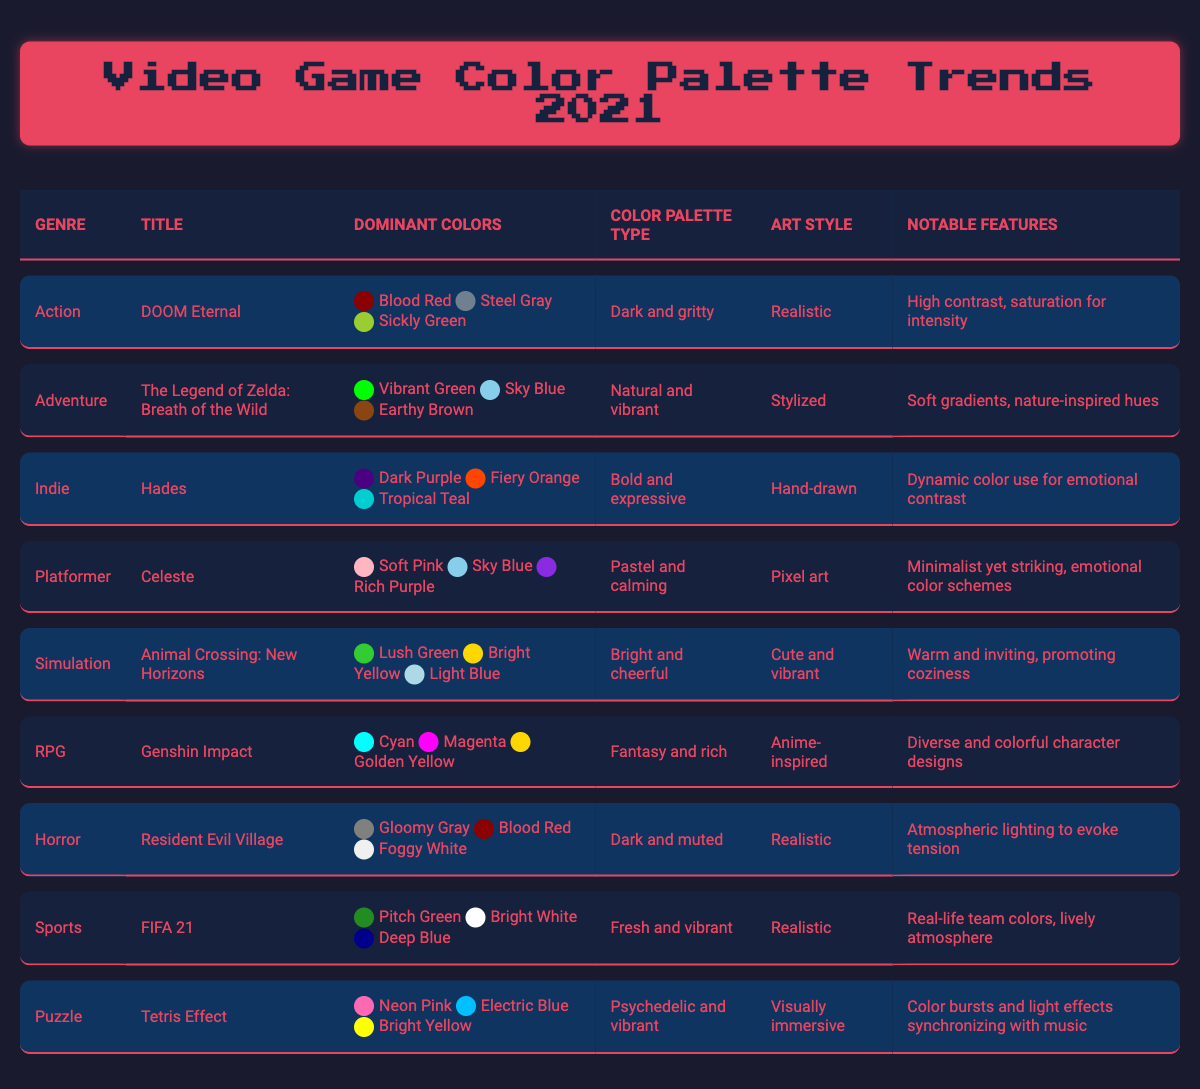What's the dominant color in "DOOM Eternal"? The table shows that the dominant colors for "DOOM Eternal" are "Blood Red," "Steel Gray," and "Sickly Green." The first listed color, "Blood Red," is typically considered the most dominant.
Answer: Blood Red Which genre does "Animal Crossing: New Horizons" belong to? Looking at the table, "Animal Crossing: New Horizons" is listed under the genre "Simulation."
Answer: Simulation What is the color palette type for "Hades"? In the table, the color palette type for "Hades" is described as "bold and expressive."
Answer: Bold and expressive True or False: "Celeste" has a color palette that is described as bright and cheerful. The table shows that "Celeste" has a color palette type of "pastel and calming," not "bright and cheerful." Hence, the statement is false.
Answer: False What are the top three dominant colors used in "Resident Evil Village"? The table states that the dominant colors for "Resident Evil Village" are "Gloomy Gray," "Blood Red," and "Foggy White."
Answer: Gloomy Gray, Blood Red, Foggy White Which art style is used in "Genshin Impact"? According to the table, "Genshin Impact" has an art style described as "anime-inspired."
Answer: Anime-inspired What is the average number of dominant colors for the listed games? There are nine games listed, each with three dominant colors. So, the total number of dominant colors is 9 games × 3 colors = 27 colors, and the average is 27/9 = 3.
Answer: 3 Which game has a color palette that is "dark and gritty"? The table indicates that "DOOM Eternal" has a color palette type described as "dark and gritty."
Answer: DOOM Eternal What is the notable feature of the color palette used in "Tetris Effect"? The notable feature of the color palette used in "Tetris Effect," as per the table, is "Color bursts and light effects synchronizing with music."
Answer: Color bursts and light effects synchronizing with music If a player enjoys vibrant greens and pastel colors, which two games might they be interested in? From the table, "Animal Crossing: New Horizons" features vibrant greens, and "Celeste" has pastel colors. Both games appeal to the player's color preferences.
Answer: Animal Crossing: New Horizons, Celeste 